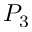<formula> <loc_0><loc_0><loc_500><loc_500>P _ { 3 }</formula> 